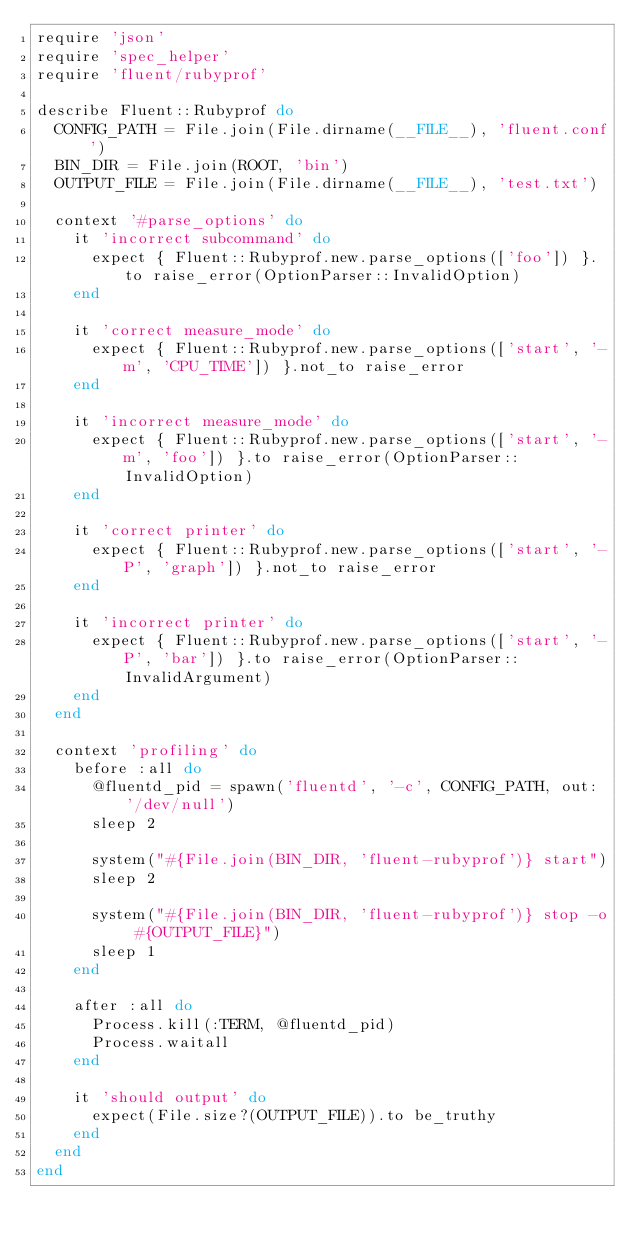<code> <loc_0><loc_0><loc_500><loc_500><_Ruby_>require 'json'
require 'spec_helper'
require 'fluent/rubyprof'

describe Fluent::Rubyprof do
  CONFIG_PATH = File.join(File.dirname(__FILE__), 'fluent.conf')
  BIN_DIR = File.join(ROOT, 'bin')
  OUTPUT_FILE = File.join(File.dirname(__FILE__), 'test.txt')

  context '#parse_options' do
    it 'incorrect subcommand' do
      expect { Fluent::Rubyprof.new.parse_options(['foo']) }.to raise_error(OptionParser::InvalidOption)
    end

    it 'correct measure_mode' do
      expect { Fluent::Rubyprof.new.parse_options(['start', '-m', 'CPU_TIME']) }.not_to raise_error
    end

    it 'incorrect measure_mode' do
      expect { Fluent::Rubyprof.new.parse_options(['start', '-m', 'foo']) }.to raise_error(OptionParser::InvalidOption)
    end

    it 'correct printer' do
      expect { Fluent::Rubyprof.new.parse_options(['start', '-P', 'graph']) }.not_to raise_error
    end

    it 'incorrect printer' do
      expect { Fluent::Rubyprof.new.parse_options(['start', '-P', 'bar']) }.to raise_error(OptionParser::InvalidArgument)
    end
  end

  context 'profiling' do
    before :all do
      @fluentd_pid = spawn('fluentd', '-c', CONFIG_PATH, out: '/dev/null')
      sleep 2

      system("#{File.join(BIN_DIR, 'fluent-rubyprof')} start")
      sleep 2

      system("#{File.join(BIN_DIR, 'fluent-rubyprof')} stop -o #{OUTPUT_FILE}")
      sleep 1
    end

    after :all do
      Process.kill(:TERM, @fluentd_pid)
      Process.waitall
    end

    it 'should output' do
      expect(File.size?(OUTPUT_FILE)).to be_truthy
    end
  end
end
</code> 